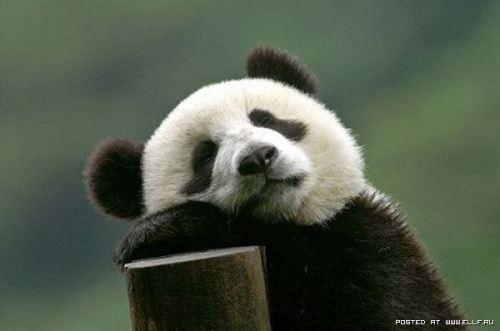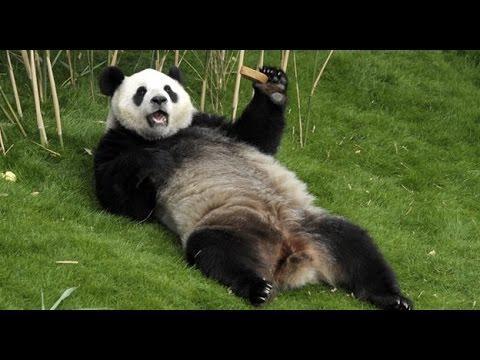The first image is the image on the left, the second image is the image on the right. Examine the images to the left and right. Is the description "At least one of the pandas is lying down." accurate? Answer yes or no. Yes. The first image is the image on the left, the second image is the image on the right. Examine the images to the left and right. Is the description "In one image, a panda is lying back with its mouth open and tongue showing." accurate? Answer yes or no. Yes. 